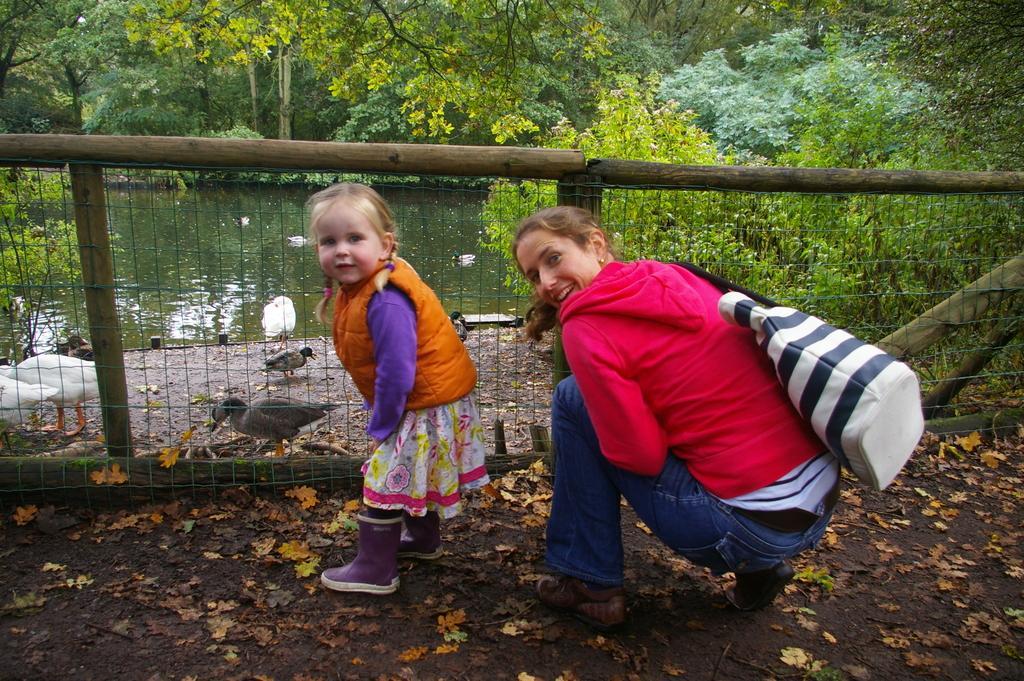Please provide a concise description of this image. There is a girl and a lady wearing a bag. In the back there is a fencing with wooden poles. On the ground there are leaves. In the background there is water, birds and trees. 